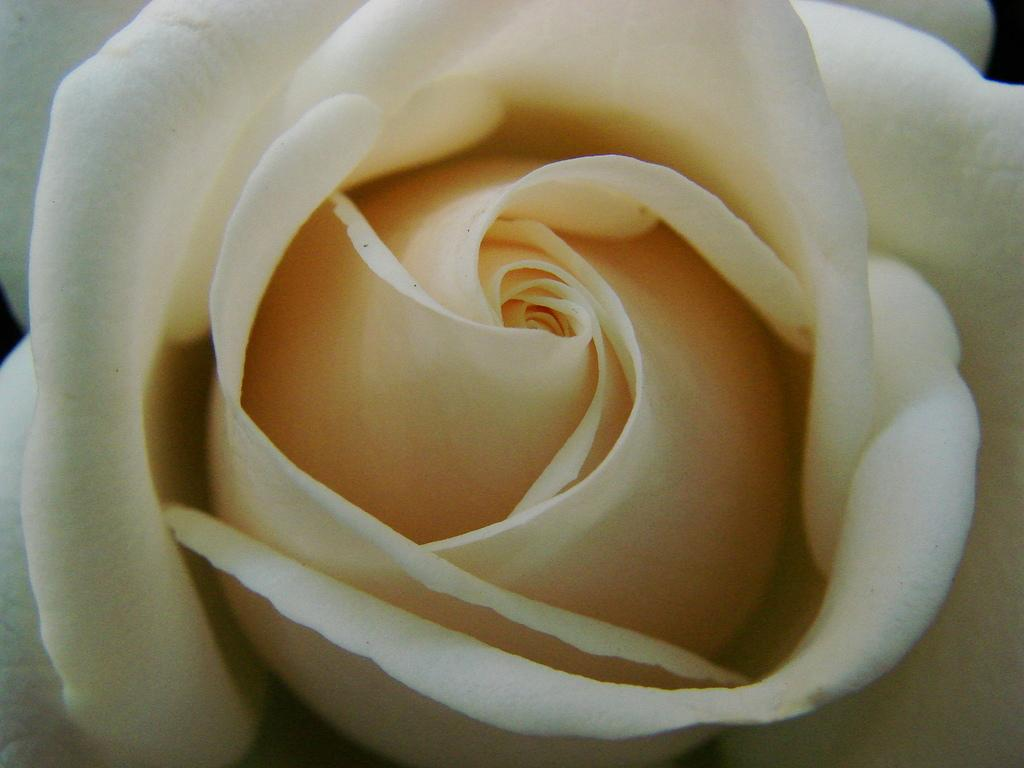What is the main subject of the image? The main subject of the image is a flower. Can you describe the colors of the flower? The flower has white and yellow colors. What type of dress is the flower wearing in the image? There is no dress present in the image, as the subject is a flower, not a person. 